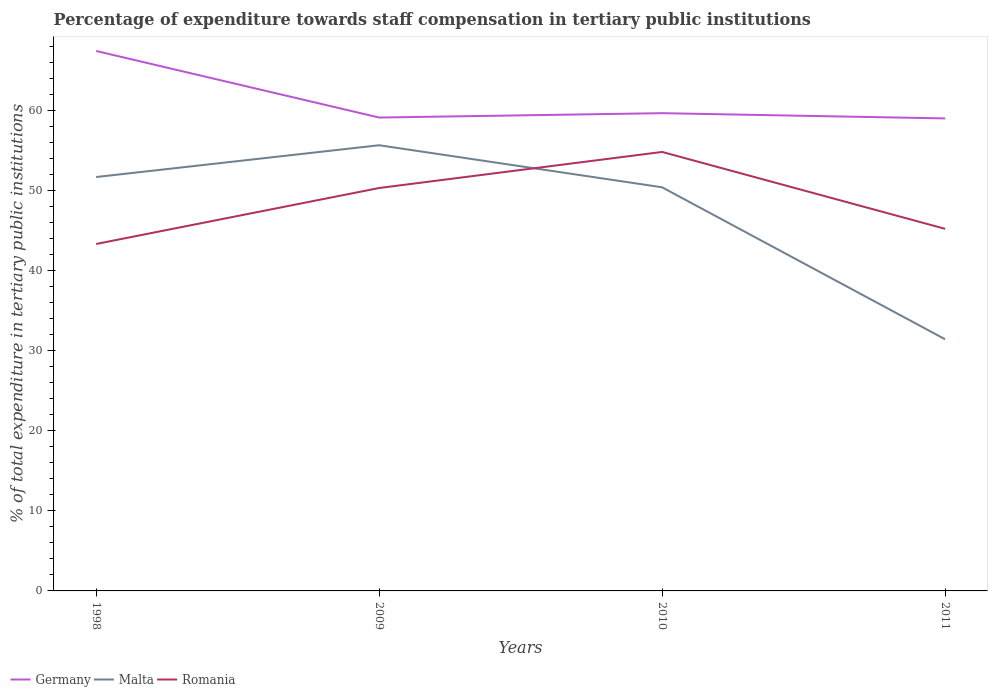How many different coloured lines are there?
Keep it short and to the point. 3. Does the line corresponding to Germany intersect with the line corresponding to Romania?
Provide a short and direct response. No. Across all years, what is the maximum percentage of expenditure towards staff compensation in Germany?
Your response must be concise. 58.97. What is the total percentage of expenditure towards staff compensation in Germany in the graph?
Give a very brief answer. 7.76. What is the difference between the highest and the second highest percentage of expenditure towards staff compensation in Romania?
Offer a terse response. 11.49. What is the difference between the highest and the lowest percentage of expenditure towards staff compensation in Romania?
Give a very brief answer. 2. How many years are there in the graph?
Offer a very short reply. 4. How many legend labels are there?
Keep it short and to the point. 3. How are the legend labels stacked?
Your response must be concise. Horizontal. What is the title of the graph?
Give a very brief answer. Percentage of expenditure towards staff compensation in tertiary public institutions. What is the label or title of the Y-axis?
Make the answer very short. % of total expenditure in tertiary public institutions. What is the % of total expenditure in tertiary public institutions in Germany in 1998?
Your answer should be very brief. 67.39. What is the % of total expenditure in tertiary public institutions in Malta in 1998?
Keep it short and to the point. 51.66. What is the % of total expenditure in tertiary public institutions of Romania in 1998?
Your answer should be very brief. 43.3. What is the % of total expenditure in tertiary public institutions of Germany in 2009?
Your answer should be very brief. 59.08. What is the % of total expenditure in tertiary public institutions in Malta in 2009?
Keep it short and to the point. 55.62. What is the % of total expenditure in tertiary public institutions in Romania in 2009?
Your answer should be compact. 50.29. What is the % of total expenditure in tertiary public institutions of Germany in 2010?
Provide a short and direct response. 59.63. What is the % of total expenditure in tertiary public institutions of Malta in 2010?
Your answer should be compact. 50.38. What is the % of total expenditure in tertiary public institutions of Romania in 2010?
Make the answer very short. 54.79. What is the % of total expenditure in tertiary public institutions in Germany in 2011?
Give a very brief answer. 58.97. What is the % of total expenditure in tertiary public institutions in Malta in 2011?
Ensure brevity in your answer.  31.41. What is the % of total expenditure in tertiary public institutions of Romania in 2011?
Make the answer very short. 45.19. Across all years, what is the maximum % of total expenditure in tertiary public institutions in Germany?
Offer a very short reply. 67.39. Across all years, what is the maximum % of total expenditure in tertiary public institutions of Malta?
Keep it short and to the point. 55.62. Across all years, what is the maximum % of total expenditure in tertiary public institutions in Romania?
Your response must be concise. 54.79. Across all years, what is the minimum % of total expenditure in tertiary public institutions of Germany?
Give a very brief answer. 58.97. Across all years, what is the minimum % of total expenditure in tertiary public institutions of Malta?
Provide a succinct answer. 31.41. Across all years, what is the minimum % of total expenditure in tertiary public institutions of Romania?
Make the answer very short. 43.3. What is the total % of total expenditure in tertiary public institutions in Germany in the graph?
Give a very brief answer. 245.07. What is the total % of total expenditure in tertiary public institutions of Malta in the graph?
Ensure brevity in your answer.  189.07. What is the total % of total expenditure in tertiary public institutions of Romania in the graph?
Your answer should be compact. 193.57. What is the difference between the % of total expenditure in tertiary public institutions in Germany in 1998 and that in 2009?
Offer a very short reply. 8.31. What is the difference between the % of total expenditure in tertiary public institutions in Malta in 1998 and that in 2009?
Your response must be concise. -3.97. What is the difference between the % of total expenditure in tertiary public institutions of Romania in 1998 and that in 2009?
Provide a succinct answer. -6.98. What is the difference between the % of total expenditure in tertiary public institutions in Germany in 1998 and that in 2010?
Give a very brief answer. 7.76. What is the difference between the % of total expenditure in tertiary public institutions in Malta in 1998 and that in 2010?
Make the answer very short. 1.28. What is the difference between the % of total expenditure in tertiary public institutions in Romania in 1998 and that in 2010?
Offer a very short reply. -11.49. What is the difference between the % of total expenditure in tertiary public institutions in Germany in 1998 and that in 2011?
Offer a terse response. 8.42. What is the difference between the % of total expenditure in tertiary public institutions of Malta in 1998 and that in 2011?
Make the answer very short. 20.24. What is the difference between the % of total expenditure in tertiary public institutions of Romania in 1998 and that in 2011?
Your answer should be compact. -1.89. What is the difference between the % of total expenditure in tertiary public institutions of Germany in 2009 and that in 2010?
Ensure brevity in your answer.  -0.54. What is the difference between the % of total expenditure in tertiary public institutions of Malta in 2009 and that in 2010?
Your answer should be compact. 5.25. What is the difference between the % of total expenditure in tertiary public institutions in Romania in 2009 and that in 2010?
Keep it short and to the point. -4.5. What is the difference between the % of total expenditure in tertiary public institutions of Germany in 2009 and that in 2011?
Your answer should be compact. 0.11. What is the difference between the % of total expenditure in tertiary public institutions in Malta in 2009 and that in 2011?
Your answer should be very brief. 24.21. What is the difference between the % of total expenditure in tertiary public institutions of Romania in 2009 and that in 2011?
Your response must be concise. 5.09. What is the difference between the % of total expenditure in tertiary public institutions in Germany in 2010 and that in 2011?
Your answer should be very brief. 0.65. What is the difference between the % of total expenditure in tertiary public institutions in Malta in 2010 and that in 2011?
Make the answer very short. 18.96. What is the difference between the % of total expenditure in tertiary public institutions of Romania in 2010 and that in 2011?
Your answer should be compact. 9.6. What is the difference between the % of total expenditure in tertiary public institutions in Germany in 1998 and the % of total expenditure in tertiary public institutions in Malta in 2009?
Your answer should be compact. 11.76. What is the difference between the % of total expenditure in tertiary public institutions of Germany in 1998 and the % of total expenditure in tertiary public institutions of Romania in 2009?
Provide a short and direct response. 17.1. What is the difference between the % of total expenditure in tertiary public institutions in Malta in 1998 and the % of total expenditure in tertiary public institutions in Romania in 2009?
Provide a short and direct response. 1.37. What is the difference between the % of total expenditure in tertiary public institutions in Germany in 1998 and the % of total expenditure in tertiary public institutions in Malta in 2010?
Give a very brief answer. 17.01. What is the difference between the % of total expenditure in tertiary public institutions of Germany in 1998 and the % of total expenditure in tertiary public institutions of Romania in 2010?
Provide a short and direct response. 12.6. What is the difference between the % of total expenditure in tertiary public institutions in Malta in 1998 and the % of total expenditure in tertiary public institutions in Romania in 2010?
Make the answer very short. -3.13. What is the difference between the % of total expenditure in tertiary public institutions in Germany in 1998 and the % of total expenditure in tertiary public institutions in Malta in 2011?
Provide a succinct answer. 35.97. What is the difference between the % of total expenditure in tertiary public institutions of Germany in 1998 and the % of total expenditure in tertiary public institutions of Romania in 2011?
Ensure brevity in your answer.  22.2. What is the difference between the % of total expenditure in tertiary public institutions of Malta in 1998 and the % of total expenditure in tertiary public institutions of Romania in 2011?
Provide a succinct answer. 6.46. What is the difference between the % of total expenditure in tertiary public institutions of Germany in 2009 and the % of total expenditure in tertiary public institutions of Malta in 2010?
Your answer should be compact. 8.7. What is the difference between the % of total expenditure in tertiary public institutions in Germany in 2009 and the % of total expenditure in tertiary public institutions in Romania in 2010?
Your response must be concise. 4.29. What is the difference between the % of total expenditure in tertiary public institutions of Malta in 2009 and the % of total expenditure in tertiary public institutions of Romania in 2010?
Offer a very short reply. 0.84. What is the difference between the % of total expenditure in tertiary public institutions in Germany in 2009 and the % of total expenditure in tertiary public institutions in Malta in 2011?
Your answer should be compact. 27.67. What is the difference between the % of total expenditure in tertiary public institutions in Germany in 2009 and the % of total expenditure in tertiary public institutions in Romania in 2011?
Offer a terse response. 13.89. What is the difference between the % of total expenditure in tertiary public institutions in Malta in 2009 and the % of total expenditure in tertiary public institutions in Romania in 2011?
Provide a short and direct response. 10.43. What is the difference between the % of total expenditure in tertiary public institutions of Germany in 2010 and the % of total expenditure in tertiary public institutions of Malta in 2011?
Offer a very short reply. 28.21. What is the difference between the % of total expenditure in tertiary public institutions of Germany in 2010 and the % of total expenditure in tertiary public institutions of Romania in 2011?
Offer a very short reply. 14.43. What is the difference between the % of total expenditure in tertiary public institutions of Malta in 2010 and the % of total expenditure in tertiary public institutions of Romania in 2011?
Give a very brief answer. 5.18. What is the average % of total expenditure in tertiary public institutions in Germany per year?
Your answer should be very brief. 61.27. What is the average % of total expenditure in tertiary public institutions of Malta per year?
Your answer should be compact. 47.27. What is the average % of total expenditure in tertiary public institutions in Romania per year?
Keep it short and to the point. 48.39. In the year 1998, what is the difference between the % of total expenditure in tertiary public institutions in Germany and % of total expenditure in tertiary public institutions in Malta?
Make the answer very short. 15.73. In the year 1998, what is the difference between the % of total expenditure in tertiary public institutions of Germany and % of total expenditure in tertiary public institutions of Romania?
Keep it short and to the point. 24.09. In the year 1998, what is the difference between the % of total expenditure in tertiary public institutions of Malta and % of total expenditure in tertiary public institutions of Romania?
Your response must be concise. 8.35. In the year 2009, what is the difference between the % of total expenditure in tertiary public institutions of Germany and % of total expenditure in tertiary public institutions of Malta?
Provide a short and direct response. 3.46. In the year 2009, what is the difference between the % of total expenditure in tertiary public institutions of Germany and % of total expenditure in tertiary public institutions of Romania?
Offer a very short reply. 8.79. In the year 2009, what is the difference between the % of total expenditure in tertiary public institutions of Malta and % of total expenditure in tertiary public institutions of Romania?
Make the answer very short. 5.34. In the year 2010, what is the difference between the % of total expenditure in tertiary public institutions in Germany and % of total expenditure in tertiary public institutions in Malta?
Your answer should be very brief. 9.25. In the year 2010, what is the difference between the % of total expenditure in tertiary public institutions of Germany and % of total expenditure in tertiary public institutions of Romania?
Keep it short and to the point. 4.84. In the year 2010, what is the difference between the % of total expenditure in tertiary public institutions of Malta and % of total expenditure in tertiary public institutions of Romania?
Give a very brief answer. -4.41. In the year 2011, what is the difference between the % of total expenditure in tertiary public institutions in Germany and % of total expenditure in tertiary public institutions in Malta?
Offer a very short reply. 27.56. In the year 2011, what is the difference between the % of total expenditure in tertiary public institutions in Germany and % of total expenditure in tertiary public institutions in Romania?
Provide a succinct answer. 13.78. In the year 2011, what is the difference between the % of total expenditure in tertiary public institutions of Malta and % of total expenditure in tertiary public institutions of Romania?
Provide a succinct answer. -13.78. What is the ratio of the % of total expenditure in tertiary public institutions of Germany in 1998 to that in 2009?
Offer a very short reply. 1.14. What is the ratio of the % of total expenditure in tertiary public institutions in Malta in 1998 to that in 2009?
Offer a very short reply. 0.93. What is the ratio of the % of total expenditure in tertiary public institutions of Romania in 1998 to that in 2009?
Ensure brevity in your answer.  0.86. What is the ratio of the % of total expenditure in tertiary public institutions in Germany in 1998 to that in 2010?
Provide a short and direct response. 1.13. What is the ratio of the % of total expenditure in tertiary public institutions in Malta in 1998 to that in 2010?
Keep it short and to the point. 1.03. What is the ratio of the % of total expenditure in tertiary public institutions of Romania in 1998 to that in 2010?
Give a very brief answer. 0.79. What is the ratio of the % of total expenditure in tertiary public institutions of Germany in 1998 to that in 2011?
Offer a very short reply. 1.14. What is the ratio of the % of total expenditure in tertiary public institutions in Malta in 1998 to that in 2011?
Provide a succinct answer. 1.64. What is the ratio of the % of total expenditure in tertiary public institutions in Romania in 1998 to that in 2011?
Give a very brief answer. 0.96. What is the ratio of the % of total expenditure in tertiary public institutions of Germany in 2009 to that in 2010?
Provide a succinct answer. 0.99. What is the ratio of the % of total expenditure in tertiary public institutions in Malta in 2009 to that in 2010?
Ensure brevity in your answer.  1.1. What is the ratio of the % of total expenditure in tertiary public institutions of Romania in 2009 to that in 2010?
Provide a succinct answer. 0.92. What is the ratio of the % of total expenditure in tertiary public institutions in Malta in 2009 to that in 2011?
Your response must be concise. 1.77. What is the ratio of the % of total expenditure in tertiary public institutions of Romania in 2009 to that in 2011?
Offer a terse response. 1.11. What is the ratio of the % of total expenditure in tertiary public institutions in Germany in 2010 to that in 2011?
Offer a very short reply. 1.01. What is the ratio of the % of total expenditure in tertiary public institutions of Malta in 2010 to that in 2011?
Offer a very short reply. 1.6. What is the ratio of the % of total expenditure in tertiary public institutions in Romania in 2010 to that in 2011?
Make the answer very short. 1.21. What is the difference between the highest and the second highest % of total expenditure in tertiary public institutions of Germany?
Ensure brevity in your answer.  7.76. What is the difference between the highest and the second highest % of total expenditure in tertiary public institutions in Malta?
Offer a terse response. 3.97. What is the difference between the highest and the second highest % of total expenditure in tertiary public institutions in Romania?
Keep it short and to the point. 4.5. What is the difference between the highest and the lowest % of total expenditure in tertiary public institutions in Germany?
Give a very brief answer. 8.42. What is the difference between the highest and the lowest % of total expenditure in tertiary public institutions of Malta?
Make the answer very short. 24.21. What is the difference between the highest and the lowest % of total expenditure in tertiary public institutions of Romania?
Provide a short and direct response. 11.49. 